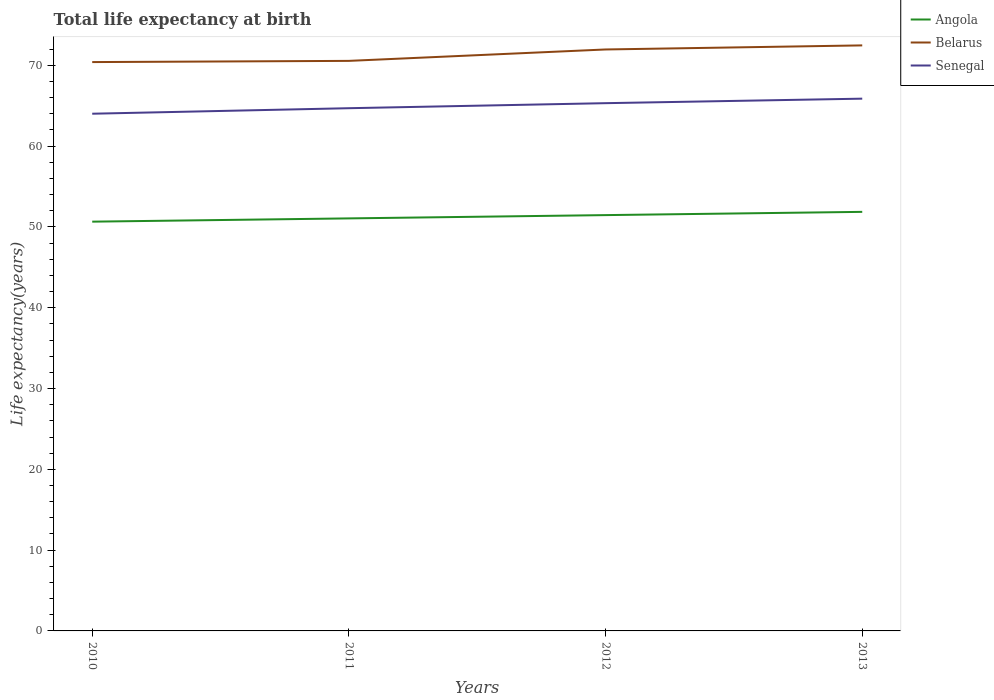Does the line corresponding to Angola intersect with the line corresponding to Belarus?
Your response must be concise. No. Is the number of lines equal to the number of legend labels?
Provide a short and direct response. Yes. Across all years, what is the maximum life expectancy at birth in in Angola?
Make the answer very short. 50.65. In which year was the life expectancy at birth in in Angola maximum?
Your answer should be very brief. 2010. What is the total life expectancy at birth in in Belarus in the graph?
Make the answer very short. -1.41. What is the difference between the highest and the second highest life expectancy at birth in in Belarus?
Your answer should be compact. 2.07. Is the life expectancy at birth in in Angola strictly greater than the life expectancy at birth in in Belarus over the years?
Ensure brevity in your answer.  Yes. How many years are there in the graph?
Provide a succinct answer. 4. What is the difference between two consecutive major ticks on the Y-axis?
Offer a terse response. 10. How many legend labels are there?
Your answer should be compact. 3. How are the legend labels stacked?
Offer a very short reply. Vertical. What is the title of the graph?
Your answer should be compact. Total life expectancy at birth. Does "Dominica" appear as one of the legend labels in the graph?
Ensure brevity in your answer.  No. What is the label or title of the X-axis?
Give a very brief answer. Years. What is the label or title of the Y-axis?
Your response must be concise. Life expectancy(years). What is the Life expectancy(years) in Angola in 2010?
Your answer should be very brief. 50.65. What is the Life expectancy(years) of Belarus in 2010?
Your response must be concise. 70.4. What is the Life expectancy(years) in Senegal in 2010?
Offer a very short reply. 64.01. What is the Life expectancy(years) in Angola in 2011?
Offer a very short reply. 51.06. What is the Life expectancy(years) in Belarus in 2011?
Make the answer very short. 70.55. What is the Life expectancy(years) in Senegal in 2011?
Give a very brief answer. 64.7. What is the Life expectancy(years) of Angola in 2012?
Your answer should be very brief. 51.46. What is the Life expectancy(years) of Belarus in 2012?
Offer a terse response. 71.97. What is the Life expectancy(years) of Senegal in 2012?
Offer a very short reply. 65.32. What is the Life expectancy(years) in Angola in 2013?
Ensure brevity in your answer.  51.87. What is the Life expectancy(years) of Belarus in 2013?
Your response must be concise. 72.47. What is the Life expectancy(years) in Senegal in 2013?
Offer a very short reply. 65.88. Across all years, what is the maximum Life expectancy(years) of Angola?
Offer a terse response. 51.87. Across all years, what is the maximum Life expectancy(years) in Belarus?
Ensure brevity in your answer.  72.47. Across all years, what is the maximum Life expectancy(years) of Senegal?
Ensure brevity in your answer.  65.88. Across all years, what is the minimum Life expectancy(years) in Angola?
Ensure brevity in your answer.  50.65. Across all years, what is the minimum Life expectancy(years) of Belarus?
Give a very brief answer. 70.4. Across all years, what is the minimum Life expectancy(years) of Senegal?
Provide a succinct answer. 64.01. What is the total Life expectancy(years) of Angola in the graph?
Provide a short and direct response. 205.04. What is the total Life expectancy(years) in Belarus in the graph?
Offer a terse response. 285.4. What is the total Life expectancy(years) in Senegal in the graph?
Give a very brief answer. 259.91. What is the difference between the Life expectancy(years) of Angola in 2010 and that in 2011?
Offer a terse response. -0.41. What is the difference between the Life expectancy(years) of Belarus in 2010 and that in 2011?
Provide a short and direct response. -0.15. What is the difference between the Life expectancy(years) in Senegal in 2010 and that in 2011?
Provide a short and direct response. -0.68. What is the difference between the Life expectancy(years) of Angola in 2010 and that in 2012?
Offer a very short reply. -0.81. What is the difference between the Life expectancy(years) of Belarus in 2010 and that in 2012?
Offer a very short reply. -1.56. What is the difference between the Life expectancy(years) of Senegal in 2010 and that in 2012?
Keep it short and to the point. -1.3. What is the difference between the Life expectancy(years) in Angola in 2010 and that in 2013?
Your response must be concise. -1.21. What is the difference between the Life expectancy(years) in Belarus in 2010 and that in 2013?
Make the answer very short. -2.07. What is the difference between the Life expectancy(years) in Senegal in 2010 and that in 2013?
Provide a succinct answer. -1.86. What is the difference between the Life expectancy(years) of Angola in 2011 and that in 2012?
Ensure brevity in your answer.  -0.4. What is the difference between the Life expectancy(years) of Belarus in 2011 and that in 2012?
Ensure brevity in your answer.  -1.41. What is the difference between the Life expectancy(years) of Senegal in 2011 and that in 2012?
Ensure brevity in your answer.  -0.62. What is the difference between the Life expectancy(years) in Angola in 2011 and that in 2013?
Provide a succinct answer. -0.81. What is the difference between the Life expectancy(years) of Belarus in 2011 and that in 2013?
Provide a succinct answer. -1.92. What is the difference between the Life expectancy(years) of Senegal in 2011 and that in 2013?
Give a very brief answer. -1.18. What is the difference between the Life expectancy(years) of Angola in 2012 and that in 2013?
Provide a short and direct response. -0.4. What is the difference between the Life expectancy(years) of Belarus in 2012 and that in 2013?
Keep it short and to the point. -0.5. What is the difference between the Life expectancy(years) of Senegal in 2012 and that in 2013?
Your answer should be compact. -0.56. What is the difference between the Life expectancy(years) of Angola in 2010 and the Life expectancy(years) of Belarus in 2011?
Your answer should be compact. -19.9. What is the difference between the Life expectancy(years) of Angola in 2010 and the Life expectancy(years) of Senegal in 2011?
Give a very brief answer. -14.04. What is the difference between the Life expectancy(years) of Belarus in 2010 and the Life expectancy(years) of Senegal in 2011?
Offer a terse response. 5.71. What is the difference between the Life expectancy(years) of Angola in 2010 and the Life expectancy(years) of Belarus in 2012?
Keep it short and to the point. -21.31. What is the difference between the Life expectancy(years) in Angola in 2010 and the Life expectancy(years) in Senegal in 2012?
Keep it short and to the point. -14.66. What is the difference between the Life expectancy(years) in Belarus in 2010 and the Life expectancy(years) in Senegal in 2012?
Offer a very short reply. 5.09. What is the difference between the Life expectancy(years) of Angola in 2010 and the Life expectancy(years) of Belarus in 2013?
Keep it short and to the point. -21.82. What is the difference between the Life expectancy(years) of Angola in 2010 and the Life expectancy(years) of Senegal in 2013?
Provide a short and direct response. -15.22. What is the difference between the Life expectancy(years) in Belarus in 2010 and the Life expectancy(years) in Senegal in 2013?
Your answer should be very brief. 4.53. What is the difference between the Life expectancy(years) in Angola in 2011 and the Life expectancy(years) in Belarus in 2012?
Provide a short and direct response. -20.91. What is the difference between the Life expectancy(years) of Angola in 2011 and the Life expectancy(years) of Senegal in 2012?
Provide a short and direct response. -14.26. What is the difference between the Life expectancy(years) of Belarus in 2011 and the Life expectancy(years) of Senegal in 2012?
Ensure brevity in your answer.  5.23. What is the difference between the Life expectancy(years) in Angola in 2011 and the Life expectancy(years) in Belarus in 2013?
Offer a terse response. -21.41. What is the difference between the Life expectancy(years) of Angola in 2011 and the Life expectancy(years) of Senegal in 2013?
Offer a very short reply. -14.82. What is the difference between the Life expectancy(years) in Belarus in 2011 and the Life expectancy(years) in Senegal in 2013?
Ensure brevity in your answer.  4.67. What is the difference between the Life expectancy(years) in Angola in 2012 and the Life expectancy(years) in Belarus in 2013?
Give a very brief answer. -21.01. What is the difference between the Life expectancy(years) of Angola in 2012 and the Life expectancy(years) of Senegal in 2013?
Ensure brevity in your answer.  -14.41. What is the difference between the Life expectancy(years) in Belarus in 2012 and the Life expectancy(years) in Senegal in 2013?
Offer a very short reply. 6.09. What is the average Life expectancy(years) of Angola per year?
Provide a short and direct response. 51.26. What is the average Life expectancy(years) of Belarus per year?
Your answer should be very brief. 71.35. What is the average Life expectancy(years) of Senegal per year?
Offer a very short reply. 64.98. In the year 2010, what is the difference between the Life expectancy(years) in Angola and Life expectancy(years) in Belarus?
Your response must be concise. -19.75. In the year 2010, what is the difference between the Life expectancy(years) of Angola and Life expectancy(years) of Senegal?
Keep it short and to the point. -13.36. In the year 2010, what is the difference between the Life expectancy(years) of Belarus and Life expectancy(years) of Senegal?
Your answer should be compact. 6.39. In the year 2011, what is the difference between the Life expectancy(years) of Angola and Life expectancy(years) of Belarus?
Your answer should be very brief. -19.49. In the year 2011, what is the difference between the Life expectancy(years) in Angola and Life expectancy(years) in Senegal?
Keep it short and to the point. -13.64. In the year 2011, what is the difference between the Life expectancy(years) in Belarus and Life expectancy(years) in Senegal?
Make the answer very short. 5.86. In the year 2012, what is the difference between the Life expectancy(years) of Angola and Life expectancy(years) of Belarus?
Provide a short and direct response. -20.5. In the year 2012, what is the difference between the Life expectancy(years) of Angola and Life expectancy(years) of Senegal?
Keep it short and to the point. -13.85. In the year 2012, what is the difference between the Life expectancy(years) of Belarus and Life expectancy(years) of Senegal?
Offer a terse response. 6.65. In the year 2013, what is the difference between the Life expectancy(years) of Angola and Life expectancy(years) of Belarus?
Your response must be concise. -20.6. In the year 2013, what is the difference between the Life expectancy(years) of Angola and Life expectancy(years) of Senegal?
Your answer should be compact. -14.01. In the year 2013, what is the difference between the Life expectancy(years) in Belarus and Life expectancy(years) in Senegal?
Provide a succinct answer. 6.59. What is the ratio of the Life expectancy(years) in Belarus in 2010 to that in 2011?
Make the answer very short. 1. What is the ratio of the Life expectancy(years) in Senegal in 2010 to that in 2011?
Provide a short and direct response. 0.99. What is the ratio of the Life expectancy(years) of Angola in 2010 to that in 2012?
Provide a succinct answer. 0.98. What is the ratio of the Life expectancy(years) of Belarus in 2010 to that in 2012?
Provide a succinct answer. 0.98. What is the ratio of the Life expectancy(years) in Angola in 2010 to that in 2013?
Provide a short and direct response. 0.98. What is the ratio of the Life expectancy(years) in Belarus in 2010 to that in 2013?
Ensure brevity in your answer.  0.97. What is the ratio of the Life expectancy(years) of Senegal in 2010 to that in 2013?
Ensure brevity in your answer.  0.97. What is the ratio of the Life expectancy(years) in Angola in 2011 to that in 2012?
Provide a short and direct response. 0.99. What is the ratio of the Life expectancy(years) of Belarus in 2011 to that in 2012?
Your answer should be compact. 0.98. What is the ratio of the Life expectancy(years) of Senegal in 2011 to that in 2012?
Your answer should be very brief. 0.99. What is the ratio of the Life expectancy(years) of Angola in 2011 to that in 2013?
Provide a succinct answer. 0.98. What is the ratio of the Life expectancy(years) of Belarus in 2011 to that in 2013?
Ensure brevity in your answer.  0.97. What is the ratio of the Life expectancy(years) of Senegal in 2011 to that in 2013?
Offer a very short reply. 0.98. What is the ratio of the Life expectancy(years) of Belarus in 2012 to that in 2013?
Make the answer very short. 0.99. What is the ratio of the Life expectancy(years) in Senegal in 2012 to that in 2013?
Ensure brevity in your answer.  0.99. What is the difference between the highest and the second highest Life expectancy(years) of Angola?
Ensure brevity in your answer.  0.4. What is the difference between the highest and the second highest Life expectancy(years) in Belarus?
Your answer should be very brief. 0.5. What is the difference between the highest and the second highest Life expectancy(years) of Senegal?
Give a very brief answer. 0.56. What is the difference between the highest and the lowest Life expectancy(years) in Angola?
Your answer should be very brief. 1.21. What is the difference between the highest and the lowest Life expectancy(years) in Belarus?
Give a very brief answer. 2.07. What is the difference between the highest and the lowest Life expectancy(years) of Senegal?
Offer a very short reply. 1.86. 